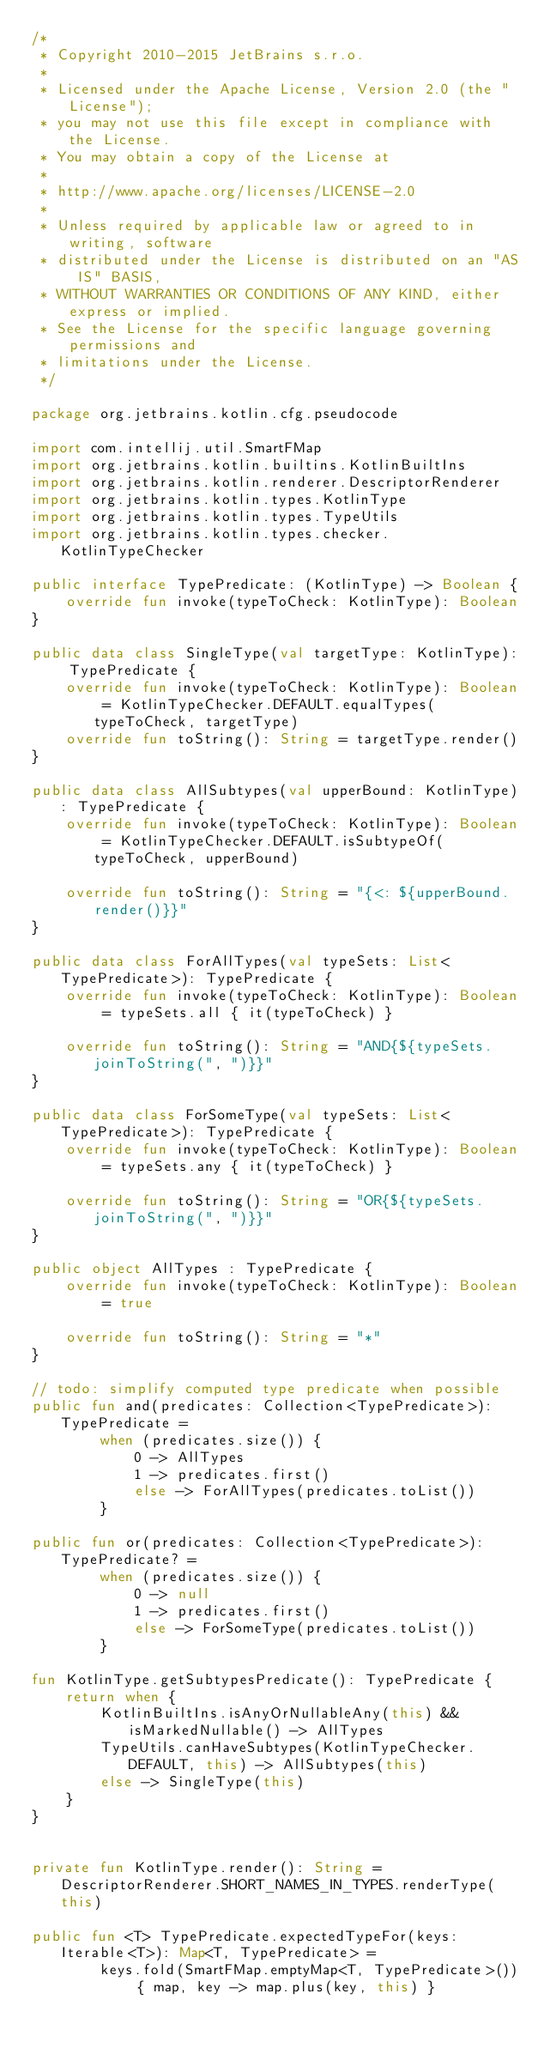<code> <loc_0><loc_0><loc_500><loc_500><_Kotlin_>/*
 * Copyright 2010-2015 JetBrains s.r.o.
 *
 * Licensed under the Apache License, Version 2.0 (the "License");
 * you may not use this file except in compliance with the License.
 * You may obtain a copy of the License at
 *
 * http://www.apache.org/licenses/LICENSE-2.0
 *
 * Unless required by applicable law or agreed to in writing, software
 * distributed under the License is distributed on an "AS IS" BASIS,
 * WITHOUT WARRANTIES OR CONDITIONS OF ANY KIND, either express or implied.
 * See the License for the specific language governing permissions and
 * limitations under the License.
 */

package org.jetbrains.kotlin.cfg.pseudocode

import com.intellij.util.SmartFMap
import org.jetbrains.kotlin.builtins.KotlinBuiltIns
import org.jetbrains.kotlin.renderer.DescriptorRenderer
import org.jetbrains.kotlin.types.KotlinType
import org.jetbrains.kotlin.types.TypeUtils
import org.jetbrains.kotlin.types.checker.KotlinTypeChecker

public interface TypePredicate: (KotlinType) -> Boolean {
    override fun invoke(typeToCheck: KotlinType): Boolean
}

public data class SingleType(val targetType: KotlinType): TypePredicate {
    override fun invoke(typeToCheck: KotlinType): Boolean = KotlinTypeChecker.DEFAULT.equalTypes(typeToCheck, targetType)
    override fun toString(): String = targetType.render()
}

public data class AllSubtypes(val upperBound: KotlinType): TypePredicate {
    override fun invoke(typeToCheck: KotlinType): Boolean = KotlinTypeChecker.DEFAULT.isSubtypeOf(typeToCheck, upperBound)

    override fun toString(): String = "{<: ${upperBound.render()}}"
}

public data class ForAllTypes(val typeSets: List<TypePredicate>): TypePredicate {
    override fun invoke(typeToCheck: KotlinType): Boolean = typeSets.all { it(typeToCheck) }

    override fun toString(): String = "AND{${typeSets.joinToString(", ")}}"
}

public data class ForSomeType(val typeSets: List<TypePredicate>): TypePredicate {
    override fun invoke(typeToCheck: KotlinType): Boolean = typeSets.any { it(typeToCheck) }

    override fun toString(): String = "OR{${typeSets.joinToString(", ")}}"
}

public object AllTypes : TypePredicate {
    override fun invoke(typeToCheck: KotlinType): Boolean = true

    override fun toString(): String = "*"
}

// todo: simplify computed type predicate when possible
public fun and(predicates: Collection<TypePredicate>): TypePredicate =
        when (predicates.size()) {
            0 -> AllTypes
            1 -> predicates.first()
            else -> ForAllTypes(predicates.toList())
        }

public fun or(predicates: Collection<TypePredicate>): TypePredicate? =
        when (predicates.size()) {
            0 -> null
            1 -> predicates.first()
            else -> ForSomeType(predicates.toList())
        }

fun KotlinType.getSubtypesPredicate(): TypePredicate {
    return when {
        KotlinBuiltIns.isAnyOrNullableAny(this) && isMarkedNullable() -> AllTypes
        TypeUtils.canHaveSubtypes(KotlinTypeChecker.DEFAULT, this) -> AllSubtypes(this)
        else -> SingleType(this)
    }
}


private fun KotlinType.render(): String = DescriptorRenderer.SHORT_NAMES_IN_TYPES.renderType(this)

public fun <T> TypePredicate.expectedTypeFor(keys: Iterable<T>): Map<T, TypePredicate> =
        keys.fold(SmartFMap.emptyMap<T, TypePredicate>()) { map, key -> map.plus(key, this) }
</code> 